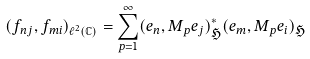<formula> <loc_0><loc_0><loc_500><loc_500>( f _ { n j } , f _ { m i } ) _ { \ell ^ { 2 } ( \mathbb { C } ) } = \sum _ { p = 1 } ^ { \infty } ( e _ { n } , M _ { p } e _ { j } ) _ { \mathfrak { H } } ^ { * } ( e _ { m } , M _ { p } e _ { i } ) _ { \mathfrak { H } }</formula> 